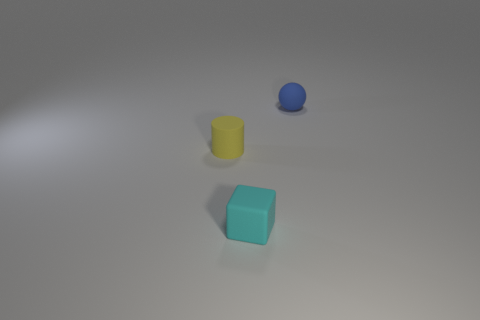The small thing that is on the right side of the object that is in front of the matte thing that is to the left of the cyan thing is what shape?
Your answer should be very brief. Sphere. How many other things are there of the same material as the tiny yellow cylinder?
Offer a very short reply. 2. Does the tiny object that is in front of the yellow matte thing have the same material as the tiny object on the right side of the small cyan matte thing?
Ensure brevity in your answer.  Yes. What number of tiny objects are both left of the small cyan cube and behind the tiny rubber cylinder?
Ensure brevity in your answer.  0. Is there a tiny cyan thing that has the same shape as the tiny yellow object?
Keep it short and to the point. No. There is a cyan thing that is the same size as the sphere; what shape is it?
Offer a very short reply. Cube. Are there an equal number of tiny blue matte objects right of the tiny ball and small cyan blocks that are behind the cylinder?
Keep it short and to the point. Yes. How big is the rubber thing in front of the tiny matte object to the left of the small cube?
Keep it short and to the point. Small. Are there any other yellow rubber cylinders of the same size as the yellow matte cylinder?
Keep it short and to the point. No. There is a cylinder that is made of the same material as the cyan thing; what is its color?
Your answer should be compact. Yellow. 